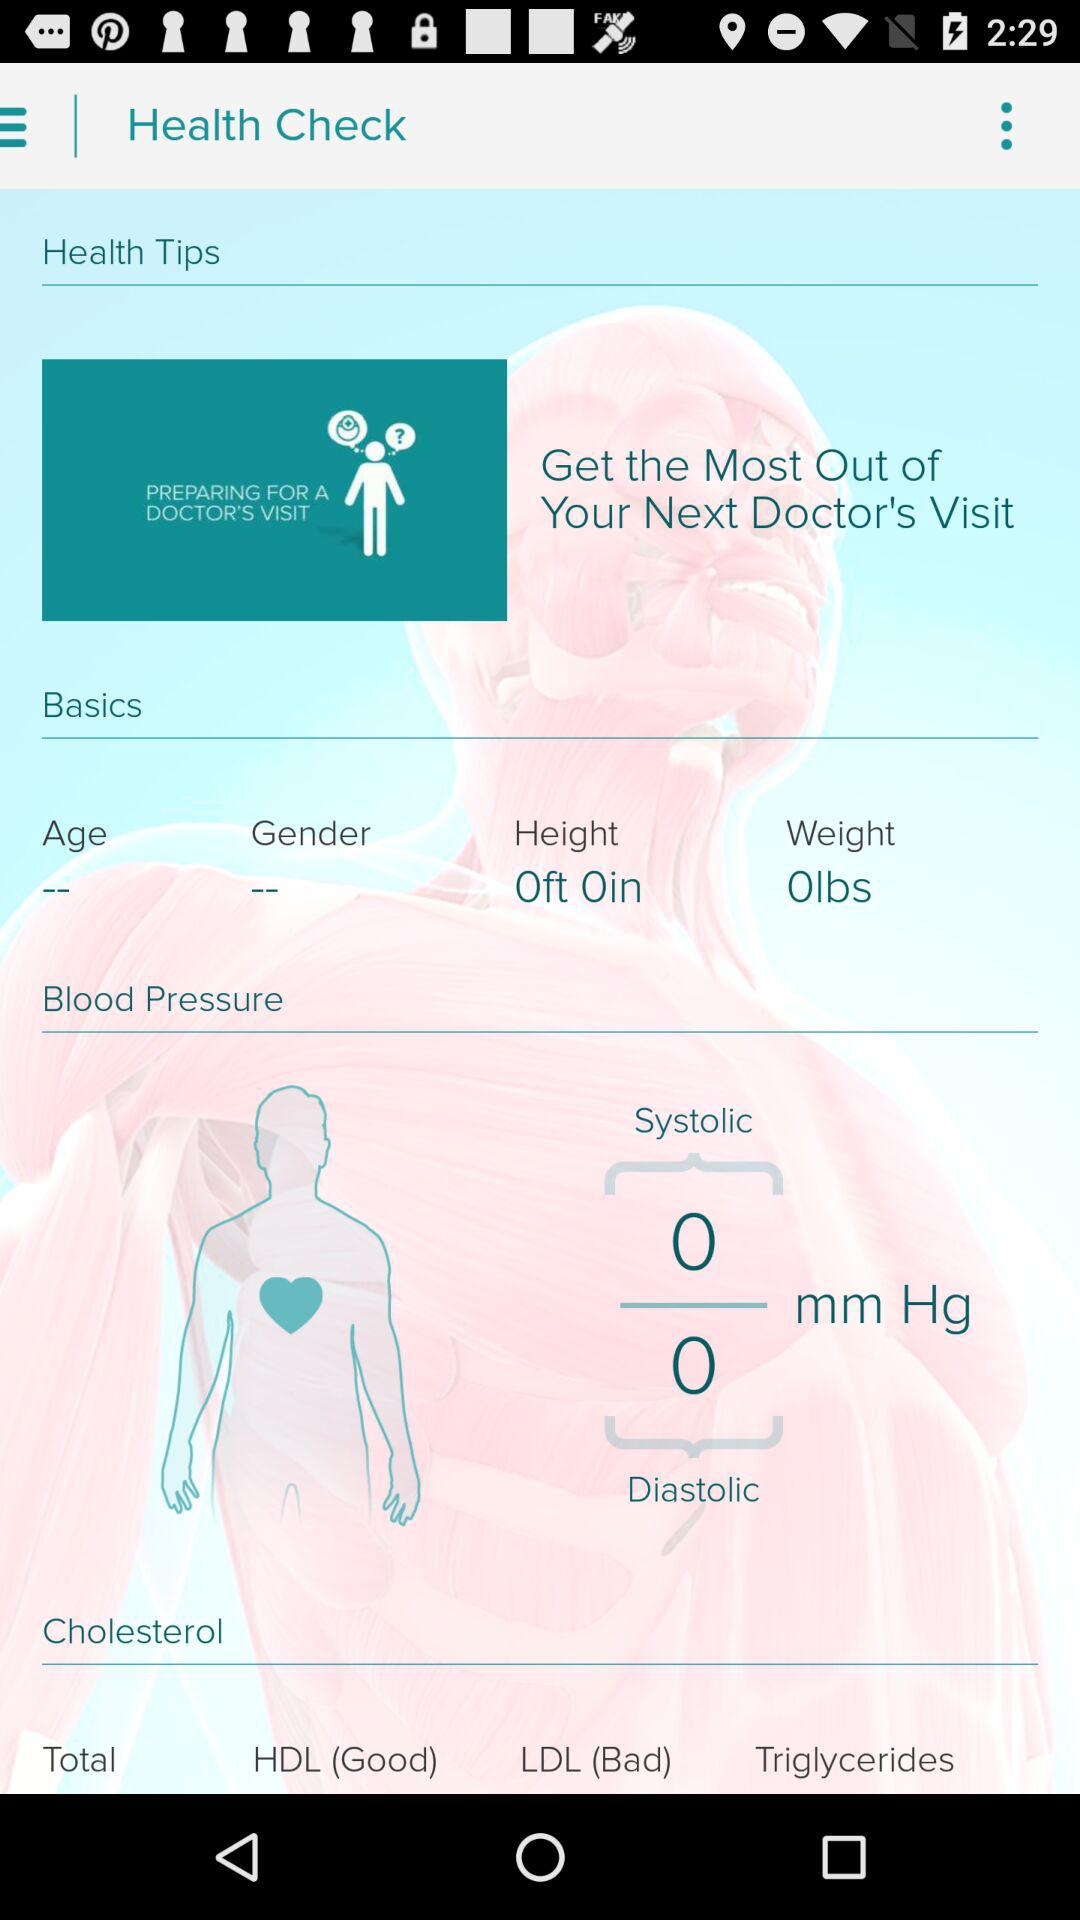What is the height? The height is 0 feet 0 inches. 